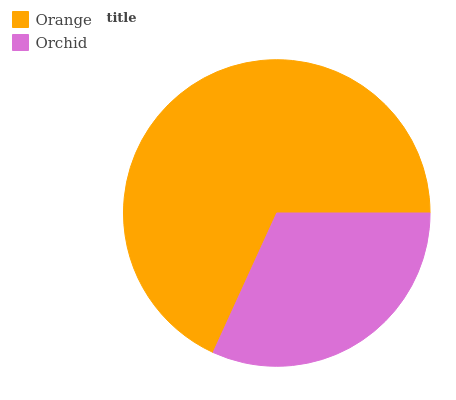Is Orchid the minimum?
Answer yes or no. Yes. Is Orange the maximum?
Answer yes or no. Yes. Is Orchid the maximum?
Answer yes or no. No. Is Orange greater than Orchid?
Answer yes or no. Yes. Is Orchid less than Orange?
Answer yes or no. Yes. Is Orchid greater than Orange?
Answer yes or no. No. Is Orange less than Orchid?
Answer yes or no. No. Is Orange the high median?
Answer yes or no. Yes. Is Orchid the low median?
Answer yes or no. Yes. Is Orchid the high median?
Answer yes or no. No. Is Orange the low median?
Answer yes or no. No. 